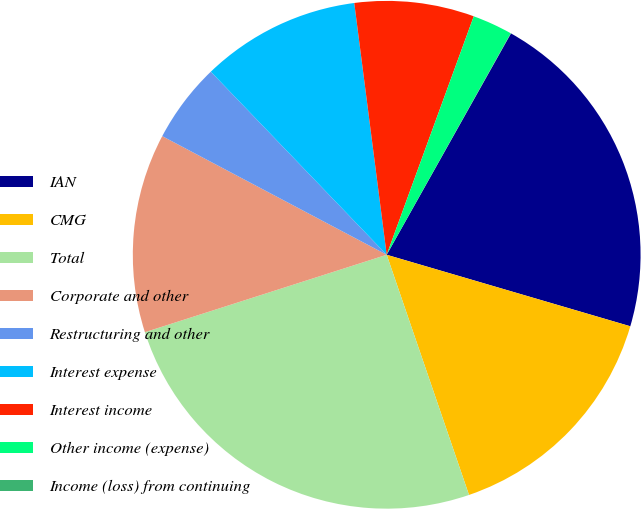Convert chart. <chart><loc_0><loc_0><loc_500><loc_500><pie_chart><fcel>IAN<fcel>CMG<fcel>Total<fcel>Corporate and other<fcel>Restructuring and other<fcel>Interest expense<fcel>Interest income<fcel>Other income (expense)<fcel>Income (loss) from continuing<nl><fcel>21.4%<fcel>15.2%<fcel>25.32%<fcel>12.67%<fcel>5.08%<fcel>10.14%<fcel>7.61%<fcel>2.55%<fcel>0.02%<nl></chart> 